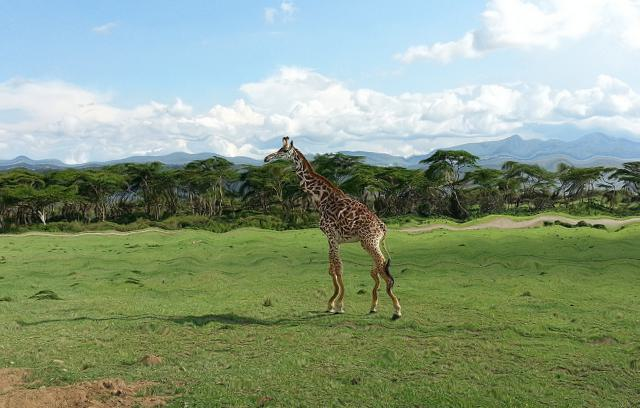Can you describe the habitat in which this giraffe is living? This giraffe appears to be in a savanna, characterized by open grassland with scattered trees. The trees seem to be acacias, which are typical in such environments. The expansive, flat terrain and sparse tree coverage allows for excellent visibility, which is ideal for giraffes that need to watch for predators. 